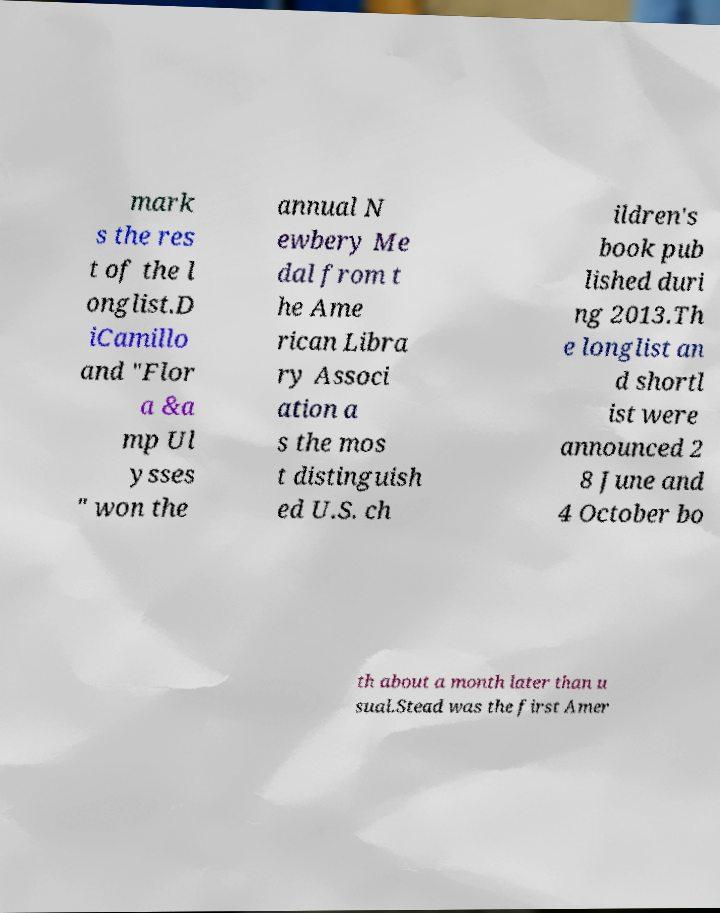Can you accurately transcribe the text from the provided image for me? mark s the res t of the l onglist.D iCamillo and "Flor a &a mp Ul ysses " won the annual N ewbery Me dal from t he Ame rican Libra ry Associ ation a s the mos t distinguish ed U.S. ch ildren's book pub lished duri ng 2013.Th e longlist an d shortl ist were announced 2 8 June and 4 October bo th about a month later than u sual.Stead was the first Amer 